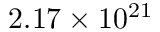Convert formula to latex. <formula><loc_0><loc_0><loc_500><loc_500>2 . 1 7 \times 1 0 ^ { 2 1 }</formula> 